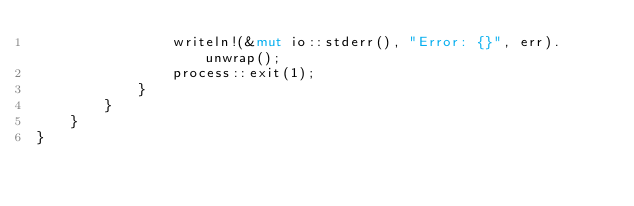<code> <loc_0><loc_0><loc_500><loc_500><_Rust_>                writeln!(&mut io::stderr(), "Error: {}", err).unwrap();
                process::exit(1);
            }
        }
    }
}
</code> 